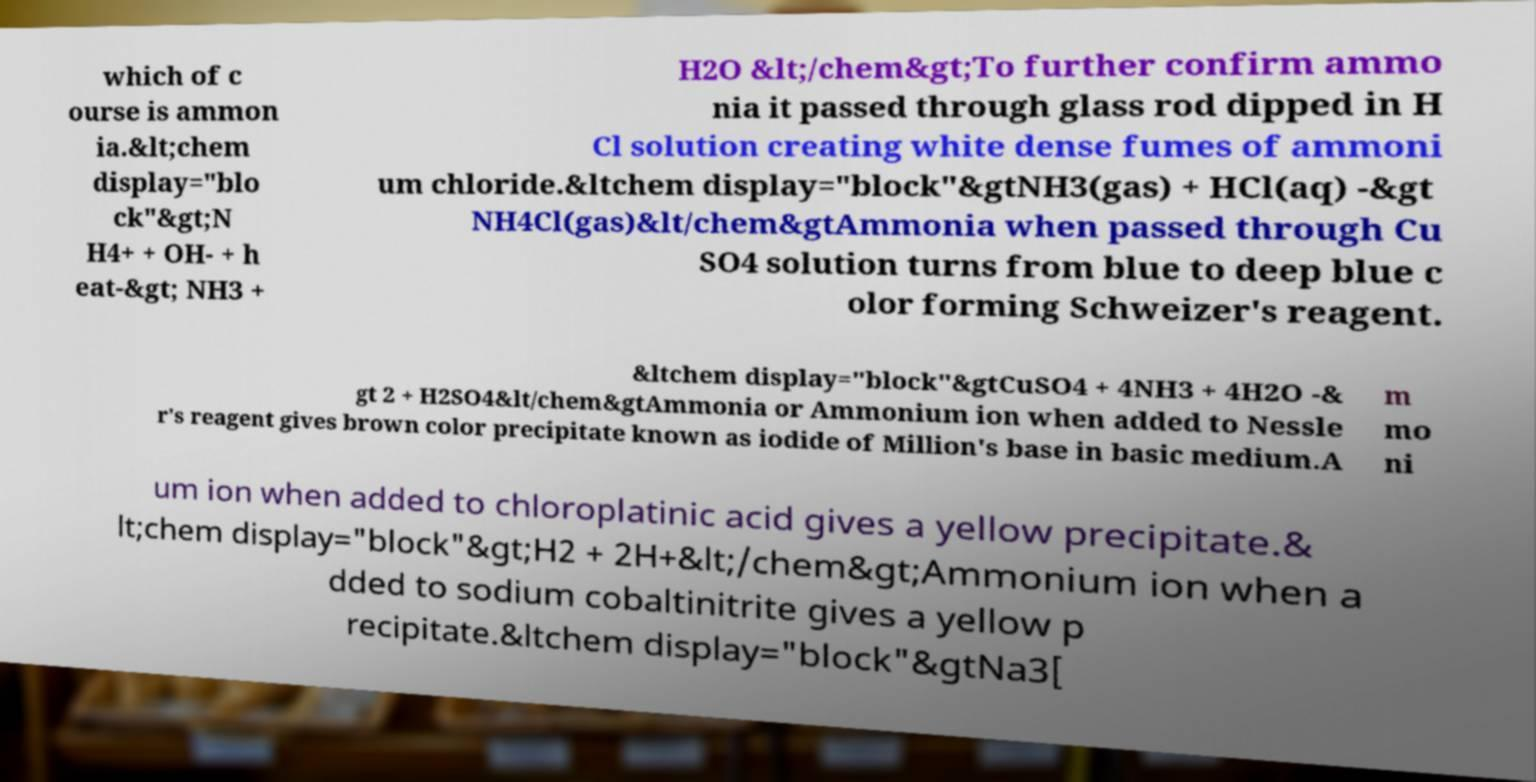Could you extract and type out the text from this image? which of c ourse is ammon ia.&lt;chem display="blo ck"&gt;N H4+ + OH- + h eat-&gt; NH3 + H2O &lt;/chem&gt;To further confirm ammo nia it passed through glass rod dipped in H Cl solution creating white dense fumes of ammoni um chloride.&ltchem display="block"&gtNH3(gas) + HCl(aq) -&gt NH4Cl(gas)&lt/chem&gtAmmonia when passed through Cu SO4 solution turns from blue to deep blue c olor forming Schweizer's reagent. &ltchem display="block"&gtCuSO4 + 4NH3 + 4H2O -& gt 2 + H2SO4&lt/chem&gtAmmonia or Ammonium ion when added to Nessle r's reagent gives brown color precipitate known as iodide of Million's base in basic medium.A m mo ni um ion when added to chloroplatinic acid gives a yellow precipitate.& lt;chem display="block"&gt;H2 + 2H+&lt;/chem&gt;Ammonium ion when a dded to sodium cobaltinitrite gives a yellow p recipitate.&ltchem display="block"&gtNa3[ 